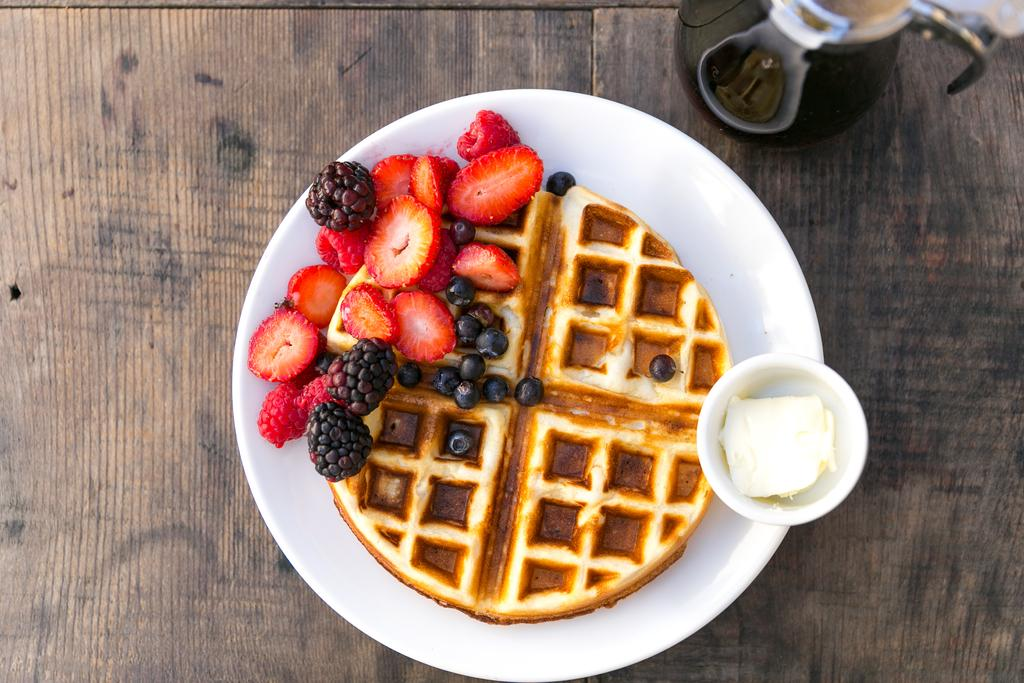What type of food items can be seen in the image? There are fruits and food items on a plate in the image. What is the container for the fruits? There is a bowl in the image for the fruits. Where are the food items and bowl located? The items are on a table in the image. What other kitchen appliance is visible in the image? There is a kettle in the image. Can you tell if the image was taken during the day or night? The image was likely taken during the day, as there is sufficient lighting. What type of collar can be seen on the rail in the image? There is no collar or rail present in the image; it features food items, a bowl, a plate, and a kettle on a table. 